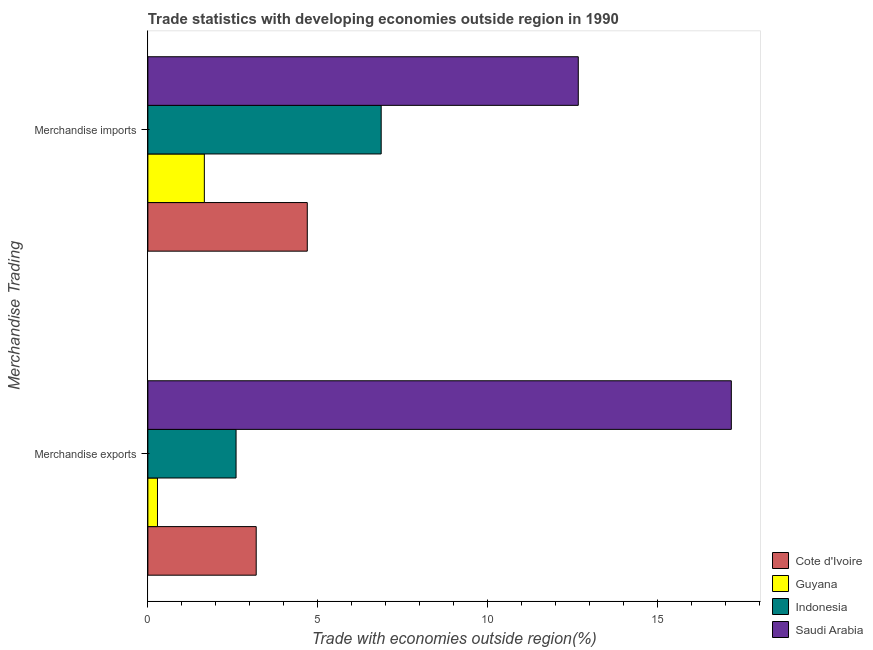How many groups of bars are there?
Provide a short and direct response. 2. Are the number of bars per tick equal to the number of legend labels?
Your response must be concise. Yes. What is the label of the 2nd group of bars from the top?
Offer a very short reply. Merchandise exports. What is the merchandise exports in Saudi Arabia?
Ensure brevity in your answer.  17.17. Across all countries, what is the maximum merchandise imports?
Offer a terse response. 12.67. Across all countries, what is the minimum merchandise exports?
Provide a succinct answer. 0.28. In which country was the merchandise exports maximum?
Offer a terse response. Saudi Arabia. In which country was the merchandise exports minimum?
Your answer should be compact. Guyana. What is the total merchandise exports in the graph?
Give a very brief answer. 23.24. What is the difference between the merchandise imports in Saudi Arabia and that in Cote d'Ivoire?
Make the answer very short. 7.98. What is the difference between the merchandise imports in Cote d'Ivoire and the merchandise exports in Saudi Arabia?
Provide a short and direct response. -12.48. What is the average merchandise imports per country?
Keep it short and to the point. 6.47. What is the difference between the merchandise imports and merchandise exports in Cote d'Ivoire?
Make the answer very short. 1.5. What is the ratio of the merchandise imports in Saudi Arabia to that in Guyana?
Offer a terse response. 7.62. In how many countries, is the merchandise exports greater than the average merchandise exports taken over all countries?
Keep it short and to the point. 1. What does the 2nd bar from the top in Merchandise exports represents?
Your answer should be very brief. Indonesia. Are all the bars in the graph horizontal?
Give a very brief answer. Yes. Does the graph contain any zero values?
Keep it short and to the point. No. Does the graph contain grids?
Offer a very short reply. No. How many legend labels are there?
Offer a terse response. 4. How are the legend labels stacked?
Provide a short and direct response. Vertical. What is the title of the graph?
Your answer should be very brief. Trade statistics with developing economies outside region in 1990. Does "Mauritius" appear as one of the legend labels in the graph?
Offer a very short reply. No. What is the label or title of the X-axis?
Keep it short and to the point. Trade with economies outside region(%). What is the label or title of the Y-axis?
Your answer should be compact. Merchandise Trading. What is the Trade with economies outside region(%) in Cote d'Ivoire in Merchandise exports?
Your answer should be compact. 3.19. What is the Trade with economies outside region(%) in Guyana in Merchandise exports?
Provide a short and direct response. 0.28. What is the Trade with economies outside region(%) of Indonesia in Merchandise exports?
Your answer should be compact. 2.6. What is the Trade with economies outside region(%) in Saudi Arabia in Merchandise exports?
Offer a very short reply. 17.17. What is the Trade with economies outside region(%) of Cote d'Ivoire in Merchandise imports?
Provide a short and direct response. 4.69. What is the Trade with economies outside region(%) of Guyana in Merchandise imports?
Your response must be concise. 1.66. What is the Trade with economies outside region(%) in Indonesia in Merchandise imports?
Offer a terse response. 6.87. What is the Trade with economies outside region(%) in Saudi Arabia in Merchandise imports?
Offer a very short reply. 12.67. Across all Merchandise Trading, what is the maximum Trade with economies outside region(%) in Cote d'Ivoire?
Keep it short and to the point. 4.69. Across all Merchandise Trading, what is the maximum Trade with economies outside region(%) of Guyana?
Provide a short and direct response. 1.66. Across all Merchandise Trading, what is the maximum Trade with economies outside region(%) of Indonesia?
Your answer should be very brief. 6.87. Across all Merchandise Trading, what is the maximum Trade with economies outside region(%) in Saudi Arabia?
Provide a succinct answer. 17.17. Across all Merchandise Trading, what is the minimum Trade with economies outside region(%) of Cote d'Ivoire?
Provide a short and direct response. 3.19. Across all Merchandise Trading, what is the minimum Trade with economies outside region(%) in Guyana?
Make the answer very short. 0.28. Across all Merchandise Trading, what is the minimum Trade with economies outside region(%) of Indonesia?
Keep it short and to the point. 2.6. Across all Merchandise Trading, what is the minimum Trade with economies outside region(%) in Saudi Arabia?
Provide a short and direct response. 12.67. What is the total Trade with economies outside region(%) in Cote d'Ivoire in the graph?
Make the answer very short. 7.88. What is the total Trade with economies outside region(%) in Guyana in the graph?
Provide a short and direct response. 1.95. What is the total Trade with economies outside region(%) in Indonesia in the graph?
Provide a succinct answer. 9.46. What is the total Trade with economies outside region(%) of Saudi Arabia in the graph?
Your response must be concise. 29.84. What is the difference between the Trade with economies outside region(%) of Cote d'Ivoire in Merchandise exports and that in Merchandise imports?
Ensure brevity in your answer.  -1.5. What is the difference between the Trade with economies outside region(%) of Guyana in Merchandise exports and that in Merchandise imports?
Offer a terse response. -1.38. What is the difference between the Trade with economies outside region(%) in Indonesia in Merchandise exports and that in Merchandise imports?
Ensure brevity in your answer.  -4.27. What is the difference between the Trade with economies outside region(%) in Saudi Arabia in Merchandise exports and that in Merchandise imports?
Offer a very short reply. 4.51. What is the difference between the Trade with economies outside region(%) of Cote d'Ivoire in Merchandise exports and the Trade with economies outside region(%) of Guyana in Merchandise imports?
Your answer should be very brief. 1.53. What is the difference between the Trade with economies outside region(%) in Cote d'Ivoire in Merchandise exports and the Trade with economies outside region(%) in Indonesia in Merchandise imports?
Offer a very short reply. -3.68. What is the difference between the Trade with economies outside region(%) in Cote d'Ivoire in Merchandise exports and the Trade with economies outside region(%) in Saudi Arabia in Merchandise imports?
Ensure brevity in your answer.  -9.48. What is the difference between the Trade with economies outside region(%) in Guyana in Merchandise exports and the Trade with economies outside region(%) in Indonesia in Merchandise imports?
Provide a succinct answer. -6.58. What is the difference between the Trade with economies outside region(%) in Guyana in Merchandise exports and the Trade with economies outside region(%) in Saudi Arabia in Merchandise imports?
Offer a terse response. -12.39. What is the difference between the Trade with economies outside region(%) in Indonesia in Merchandise exports and the Trade with economies outside region(%) in Saudi Arabia in Merchandise imports?
Offer a terse response. -10.07. What is the average Trade with economies outside region(%) of Cote d'Ivoire per Merchandise Trading?
Offer a very short reply. 3.94. What is the average Trade with economies outside region(%) in Guyana per Merchandise Trading?
Make the answer very short. 0.97. What is the average Trade with economies outside region(%) in Indonesia per Merchandise Trading?
Give a very brief answer. 4.73. What is the average Trade with economies outside region(%) of Saudi Arabia per Merchandise Trading?
Offer a very short reply. 14.92. What is the difference between the Trade with economies outside region(%) in Cote d'Ivoire and Trade with economies outside region(%) in Guyana in Merchandise exports?
Ensure brevity in your answer.  2.91. What is the difference between the Trade with economies outside region(%) in Cote d'Ivoire and Trade with economies outside region(%) in Indonesia in Merchandise exports?
Offer a terse response. 0.59. What is the difference between the Trade with economies outside region(%) in Cote d'Ivoire and Trade with economies outside region(%) in Saudi Arabia in Merchandise exports?
Ensure brevity in your answer.  -13.99. What is the difference between the Trade with economies outside region(%) in Guyana and Trade with economies outside region(%) in Indonesia in Merchandise exports?
Give a very brief answer. -2.31. What is the difference between the Trade with economies outside region(%) in Guyana and Trade with economies outside region(%) in Saudi Arabia in Merchandise exports?
Keep it short and to the point. -16.89. What is the difference between the Trade with economies outside region(%) of Indonesia and Trade with economies outside region(%) of Saudi Arabia in Merchandise exports?
Your answer should be very brief. -14.58. What is the difference between the Trade with economies outside region(%) of Cote d'Ivoire and Trade with economies outside region(%) of Guyana in Merchandise imports?
Keep it short and to the point. 3.03. What is the difference between the Trade with economies outside region(%) of Cote d'Ivoire and Trade with economies outside region(%) of Indonesia in Merchandise imports?
Provide a short and direct response. -2.18. What is the difference between the Trade with economies outside region(%) in Cote d'Ivoire and Trade with economies outside region(%) in Saudi Arabia in Merchandise imports?
Provide a succinct answer. -7.98. What is the difference between the Trade with economies outside region(%) of Guyana and Trade with economies outside region(%) of Indonesia in Merchandise imports?
Your answer should be very brief. -5.21. What is the difference between the Trade with economies outside region(%) of Guyana and Trade with economies outside region(%) of Saudi Arabia in Merchandise imports?
Your answer should be very brief. -11.01. What is the difference between the Trade with economies outside region(%) in Indonesia and Trade with economies outside region(%) in Saudi Arabia in Merchandise imports?
Provide a short and direct response. -5.8. What is the ratio of the Trade with economies outside region(%) in Cote d'Ivoire in Merchandise exports to that in Merchandise imports?
Offer a terse response. 0.68. What is the ratio of the Trade with economies outside region(%) in Guyana in Merchandise exports to that in Merchandise imports?
Your answer should be compact. 0.17. What is the ratio of the Trade with economies outside region(%) in Indonesia in Merchandise exports to that in Merchandise imports?
Your answer should be compact. 0.38. What is the ratio of the Trade with economies outside region(%) in Saudi Arabia in Merchandise exports to that in Merchandise imports?
Offer a terse response. 1.36. What is the difference between the highest and the second highest Trade with economies outside region(%) of Cote d'Ivoire?
Give a very brief answer. 1.5. What is the difference between the highest and the second highest Trade with economies outside region(%) of Guyana?
Provide a short and direct response. 1.38. What is the difference between the highest and the second highest Trade with economies outside region(%) of Indonesia?
Provide a short and direct response. 4.27. What is the difference between the highest and the second highest Trade with economies outside region(%) in Saudi Arabia?
Give a very brief answer. 4.51. What is the difference between the highest and the lowest Trade with economies outside region(%) of Cote d'Ivoire?
Provide a succinct answer. 1.5. What is the difference between the highest and the lowest Trade with economies outside region(%) in Guyana?
Your answer should be compact. 1.38. What is the difference between the highest and the lowest Trade with economies outside region(%) of Indonesia?
Provide a succinct answer. 4.27. What is the difference between the highest and the lowest Trade with economies outside region(%) in Saudi Arabia?
Your answer should be compact. 4.51. 